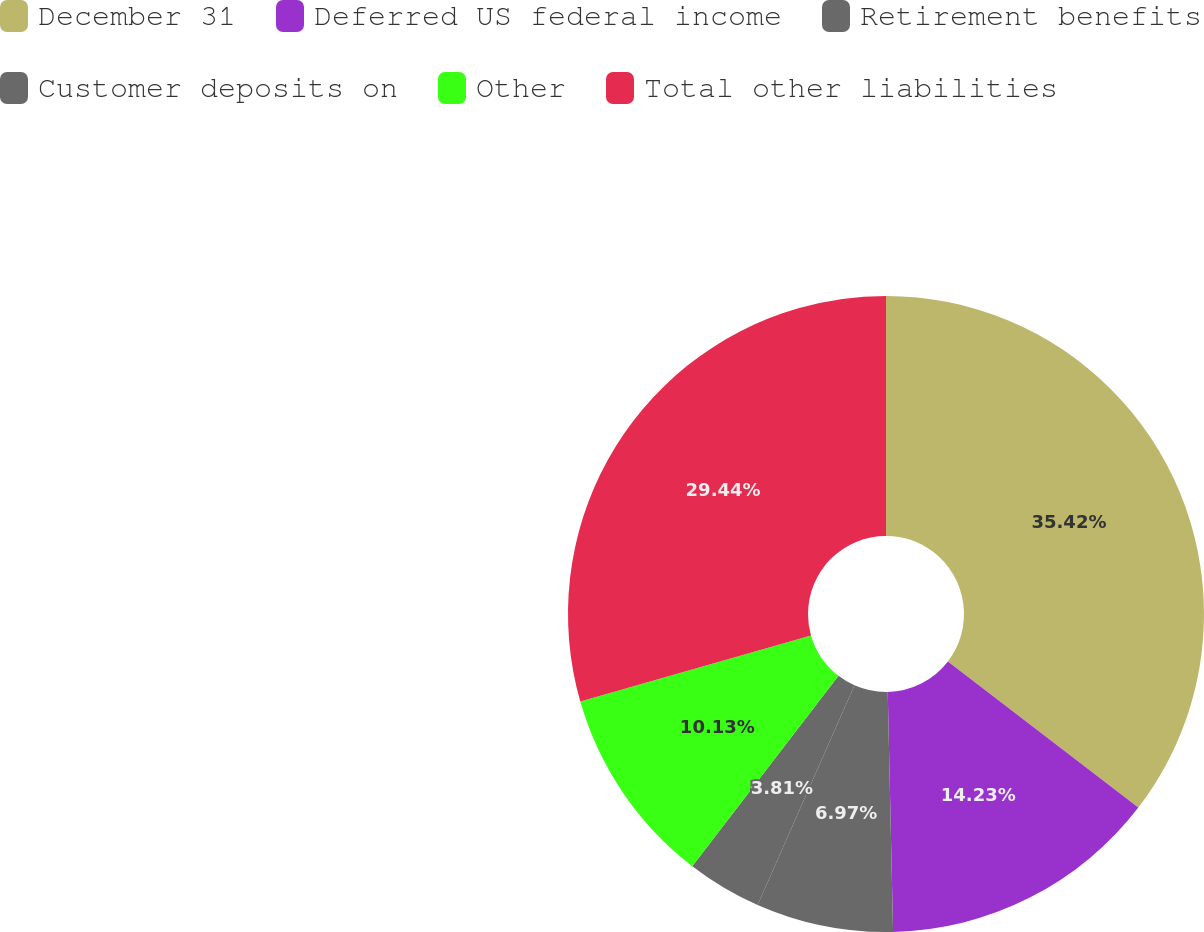Convert chart. <chart><loc_0><loc_0><loc_500><loc_500><pie_chart><fcel>December 31<fcel>Deferred US federal income<fcel>Retirement benefits<fcel>Customer deposits on<fcel>Other<fcel>Total other liabilities<nl><fcel>35.41%<fcel>14.23%<fcel>6.97%<fcel>3.81%<fcel>10.13%<fcel>29.44%<nl></chart> 